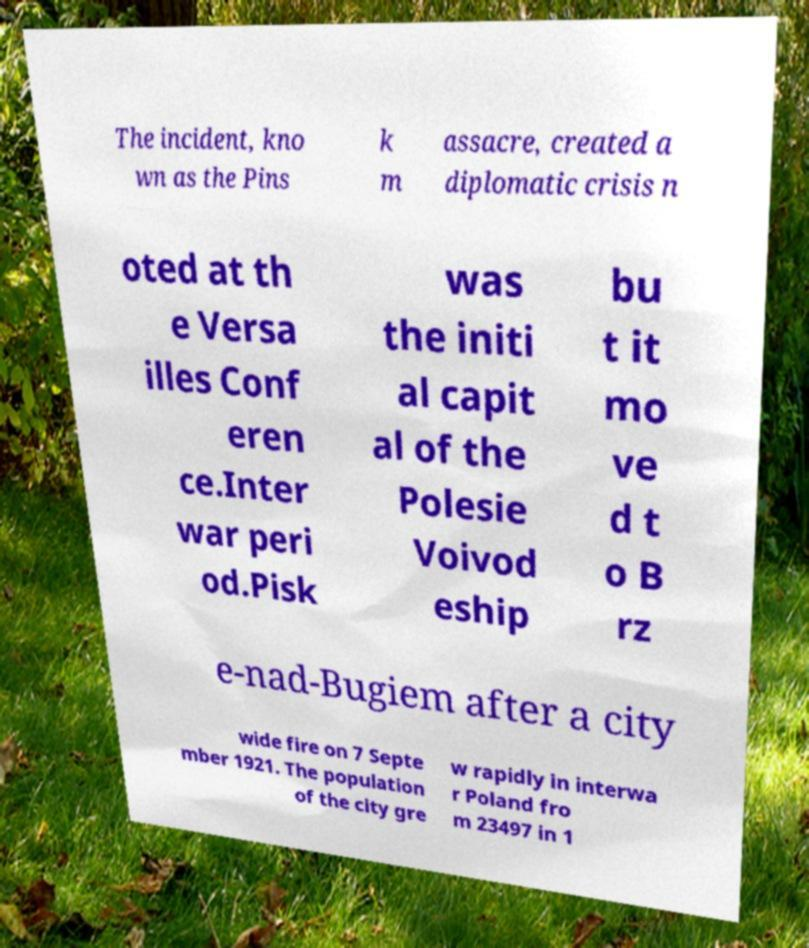For documentation purposes, I need the text within this image transcribed. Could you provide that? The incident, kno wn as the Pins k m assacre, created a diplomatic crisis n oted at th e Versa illes Conf eren ce.Inter war peri od.Pisk was the initi al capit al of the Polesie Voivod eship bu t it mo ve d t o B rz e-nad-Bugiem after a city wide fire on 7 Septe mber 1921. The population of the city gre w rapidly in interwa r Poland fro m 23497 in 1 